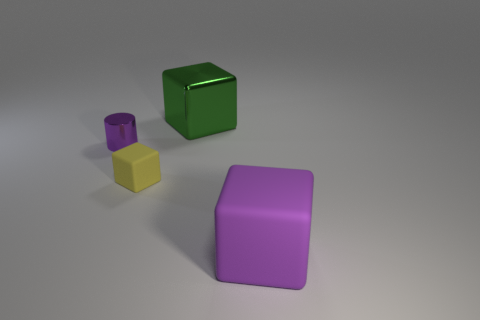What is the material of the thing that is the same size as the yellow cube?
Provide a succinct answer. Metal. Is the shape of the green metallic thing the same as the large rubber object?
Your response must be concise. Yes. What number of things are either purple balls or large things that are left of the purple rubber thing?
Offer a very short reply. 1. There is a big object that is the same color as the tiny cylinder; what is its material?
Give a very brief answer. Rubber. There is a purple object that is to the left of the metallic cube; does it have the same size as the large green metal cube?
Your response must be concise. No. There is a purple object that is right of the large object that is behind the yellow matte thing; what number of big matte cubes are in front of it?
Offer a terse response. 0. How many green things are big blocks or large shiny cubes?
Make the answer very short. 1. What color is the big thing that is made of the same material as the cylinder?
Your answer should be compact. Green. Is there anything else that has the same size as the green shiny block?
Provide a succinct answer. Yes. How many small objects are shiny objects or rubber objects?
Keep it short and to the point. 2. 